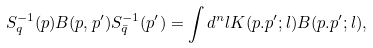Convert formula to latex. <formula><loc_0><loc_0><loc_500><loc_500>S _ { q } ^ { - 1 } ( p ) B ( p , p ^ { \prime } ) S _ { \bar { q } } ^ { - 1 } ( p ^ { \prime } ) = \int d ^ { n } l K ( p . p ^ { \prime } ; l ) B ( p . p ^ { \prime } ; l ) ,</formula> 